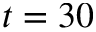<formula> <loc_0><loc_0><loc_500><loc_500>t = 3 0</formula> 